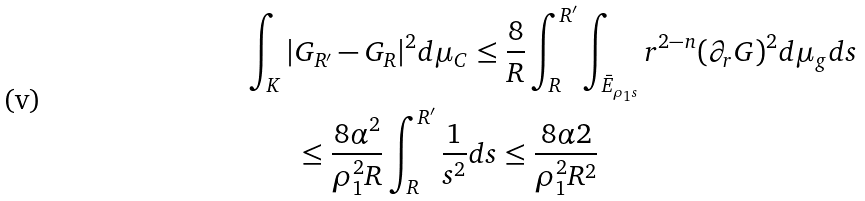Convert formula to latex. <formula><loc_0><loc_0><loc_500><loc_500>\int _ { K } | & G _ { R ^ { \prime } } - G _ { R } | ^ { 2 } d \mu _ { C } \leq \frac { 8 } { R } \int _ { R } ^ { R ^ { \prime } } \int _ { \bar { E } _ { \rho _ { 1 } s } } r ^ { 2 - n } ( \partial _ { r } G ) ^ { 2 } d \mu _ { g } d s \\ & \leq \frac { 8 \alpha ^ { 2 } } { \rho _ { 1 } ^ { 2 } R } \int _ { R } ^ { R ^ { \prime } } \frac { 1 } { s ^ { 2 } } d s \leq \frac { 8 \alpha 2 } { \rho _ { 1 } ^ { 2 } R ^ { 2 } }</formula> 